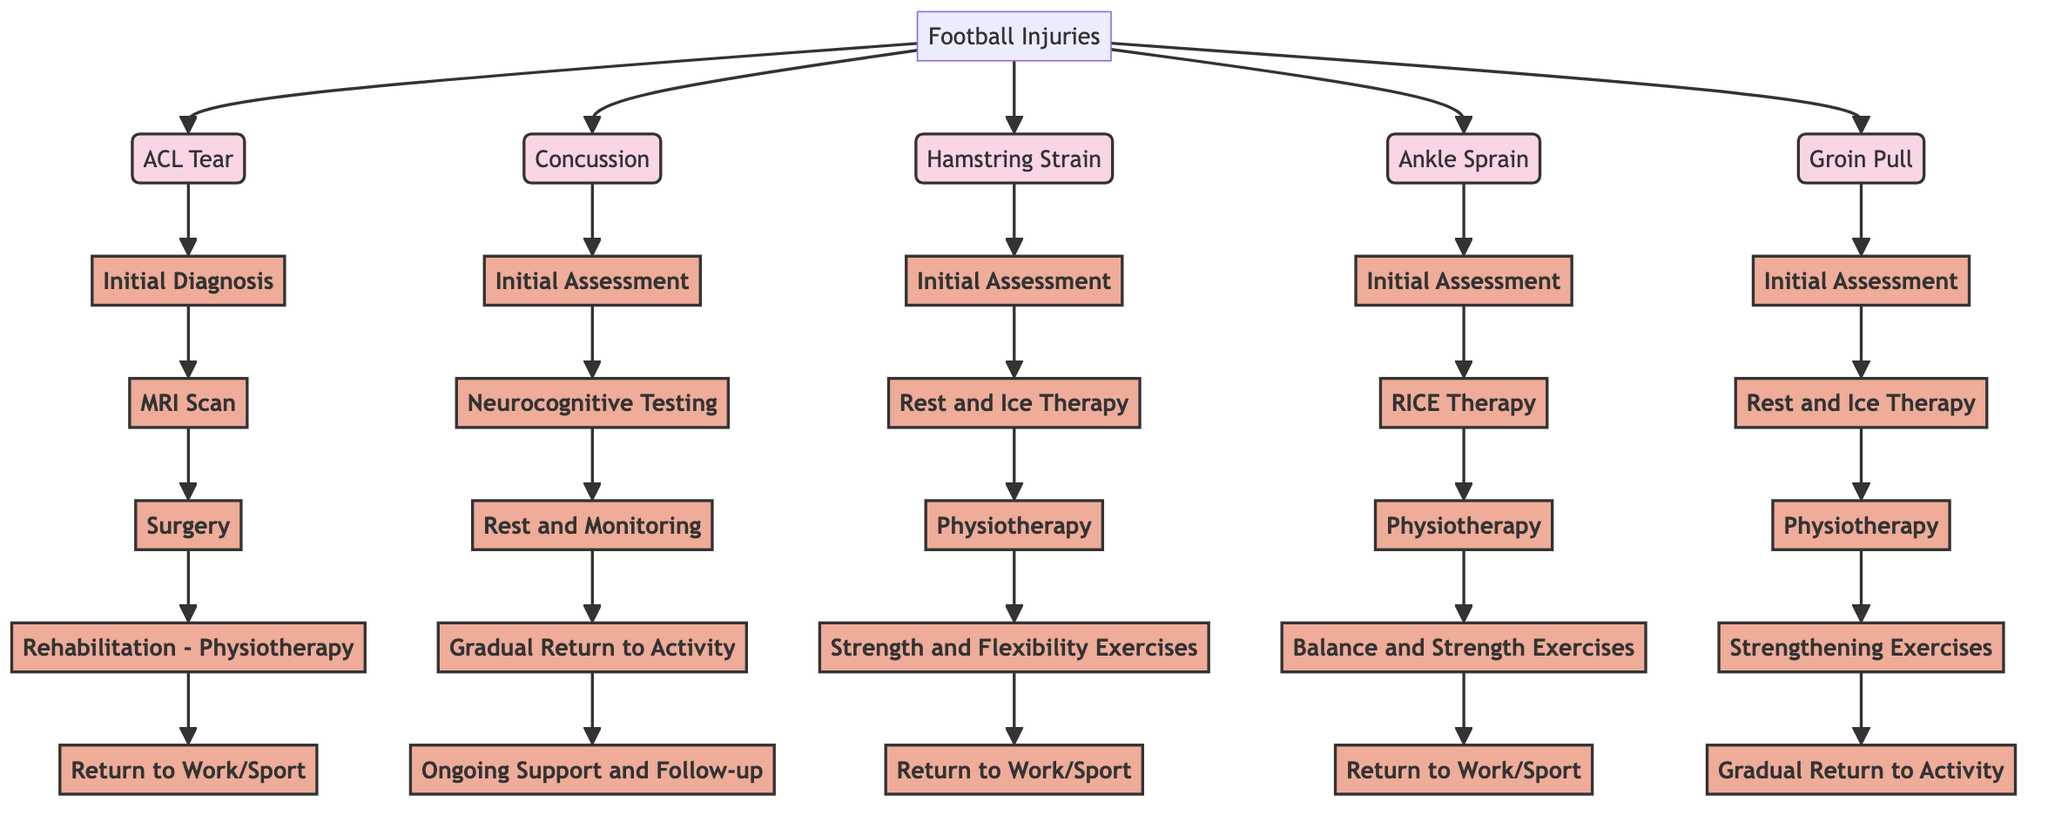What are the common football injuries listed in the diagram? The diagram specifically lists five common football injuries: ACL Tear, Concussion, Hamstring Strain, Ankle Sprain, and Groin Pull. These are all identified in the first part of the diagram under the "Football Injuries" node.
Answer: ACL Tear, Concussion, Hamstring Strain, Ankle Sprain, Groin Pull What is the total time off work for an ACL Tear? The diagram states that the time off work for an ACL Tear is between 6-9 months. This is directly connected to the economic impact section for this specific injury.
Answer: 6-9 months How many stages are involved in the treatment pathway for a Hamstring Strain? The treatment pathway for a Hamstring Strain includes five stages: Initial Assessment, Rest and Ice Therapy, Physiotherapy, Strength and Flexibility Exercises, and Return to Work/Sport. Each step is a distinct node in the treatment pathway for this injury.
Answer: 5 What is the economic loss associated with a Concussion? The economic loss stated for a Concussion in the economic impact section of the diagram is $10,000. This figure is listed directly under the costs related to this specific injury.
Answer: $10,000 Which treatment pathway step follows "Rest and Monitoring" for a Concussion? After the "Rest and Monitoring" step, the next step in the treatment pathway for a Concussion is "Gradual Return to Activity." This is the fourth node in the series pertaining to this injury.
Answer: Gradual Return to Activity What is the total cost for surgery and rehabilitation for an ACL Tear? The total cost for surgery and rehabilitation combines the surgery cost of $20,000 and the rehabilitation cost of $5,000, leading to a total of $25,000. This calculation is based on the economic impact data provided for this injury.
Answer: $25,000 What type of therapy is recommended first for an Ankle Sprain? The recommended first therapy for an Ankle Sprain, according to the treatment pathway, is RICE (Rest, Ice, Compression, Elevation). This step is listed immediately after the Initial Assessment node.
Answer: RICE What is the common pathway step for both Groin Pull and Hamstring Strain after initial assessment? Both injuries have "Physiotherapy" as the common step after the Initial Assessment in their respective pathways. Observing the flows, this step directly follows the initial assessment in both treatment pathways.
Answer: Physiotherapy What diagram structure type does the economic impact of injuries represent? The economic impact data for each injury represents a structured relationship of costs and economic loss which helps viewers understand the financial implications of each injury. Since this section categorizes costs, it is descriptive in nature and outlines relationships between injuries and their financial impacts comprehensively.
Answer: Descriptive structure 